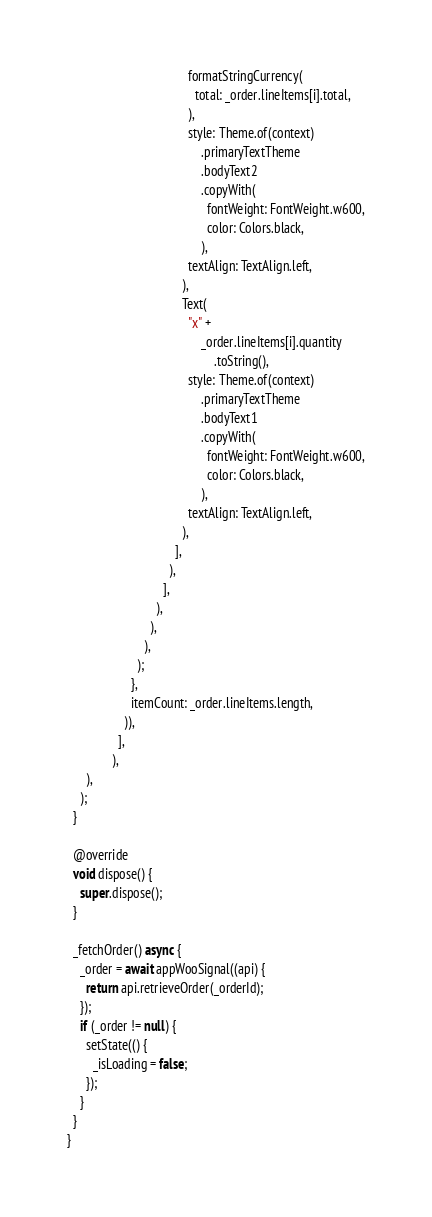<code> <loc_0><loc_0><loc_500><loc_500><_Dart_>                                      formatStringCurrency(
                                        total: _order.lineItems[i].total,
                                      ),
                                      style: Theme.of(context)
                                          .primaryTextTheme
                                          .bodyText2
                                          .copyWith(
                                            fontWeight: FontWeight.w600,
                                            color: Colors.black,
                                          ),
                                      textAlign: TextAlign.left,
                                    ),
                                    Text(
                                      "x" +
                                          _order.lineItems[i].quantity
                                              .toString(),
                                      style: Theme.of(context)
                                          .primaryTextTheme
                                          .bodyText1
                                          .copyWith(
                                            fontWeight: FontWeight.w600,
                                            color: Colors.black,
                                          ),
                                      textAlign: TextAlign.left,
                                    ),
                                  ],
                                ),
                              ],
                            ),
                          ),
                        ),
                      );
                    },
                    itemCount: _order.lineItems.length,
                  )),
                ],
              ),
      ),
    );
  }

  @override
  void dispose() {
    super.dispose();
  }

  _fetchOrder() async {
    _order = await appWooSignal((api) {
      return api.retrieveOrder(_orderId);
    });
    if (_order != null) {
      setState(() {
        _isLoading = false;
      });
    }
  }
}
</code> 